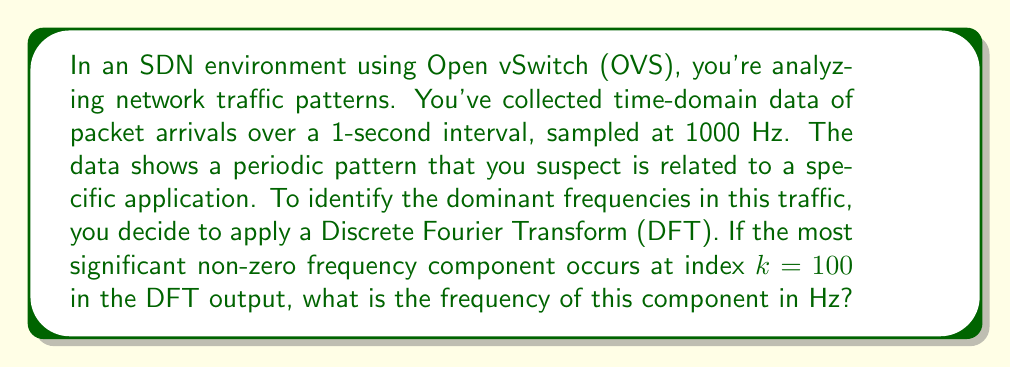Help me with this question. To solve this problem, we need to understand the relationship between the DFT output and the actual frequencies in the signal. Let's break it down step-by-step:

1) The Discrete Fourier Transform (DFT) converts a finite sequence of equally-spaced samples of a function into a same-length sequence of equally-spaced samples of the discrete-time Fourier transform.

2) In this case, we have:
   - Sampling rate ($f_s$) = 1000 Hz
   - Total time (T) = 1 second
   - Number of samples (N) = $f_s * T = 1000 * 1 = 1000$

3) The frequency resolution of the DFT is given by:

   $$\Delta f = \frac{f_s}{N} = \frac{1000}{1000} = 1 \text{ Hz}$$

4) In the DFT output, the frequencies are represented by indices k, where:
   - k = 0 corresponds to 0 Hz (DC component)
   - k = 1 to N/2 correspond to positive frequencies
   - k = N/2+1 to N-1 correspond to negative frequencies (which are typically ignored for real-valued inputs)

5) The relationship between the index k and the actual frequency f is:

   $$f = k * \Delta f$$

6) In this problem, we're told that the most significant non-zero frequency component occurs at k = 100.

7) Therefore, the frequency of this component is:

   $$f = 100 * 1 \text{ Hz} = 100 \text{ Hz}$$

This 100 Hz frequency likely represents a recurring pattern in the network traffic, possibly related to a specific application's behavior or a network protocol's timing.
Answer: 100 Hz 